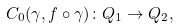<formula> <loc_0><loc_0><loc_500><loc_500>C _ { 0 } ( \gamma , f \circ \gamma ) \colon Q _ { 1 } \to Q _ { 2 } ,</formula> 